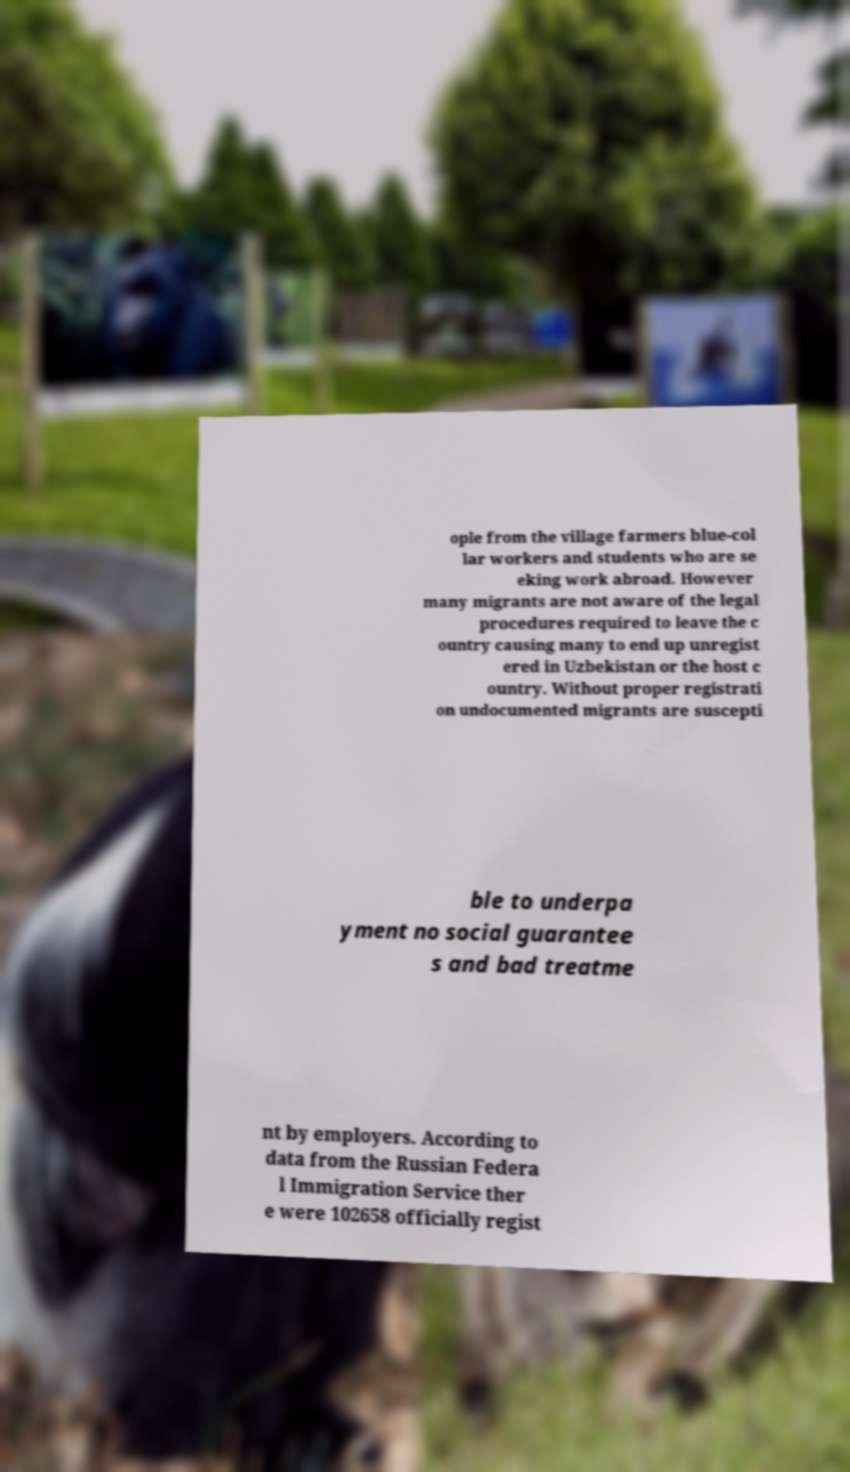I need the written content from this picture converted into text. Can you do that? ople from the village farmers blue-col lar workers and students who are se eking work abroad. However many migrants are not aware of the legal procedures required to leave the c ountry causing many to end up unregist ered in Uzbekistan or the host c ountry. Without proper registrati on undocumented migrants are suscepti ble to underpa yment no social guarantee s and bad treatme nt by employers. According to data from the Russian Federa l Immigration Service ther e were 102658 officially regist 